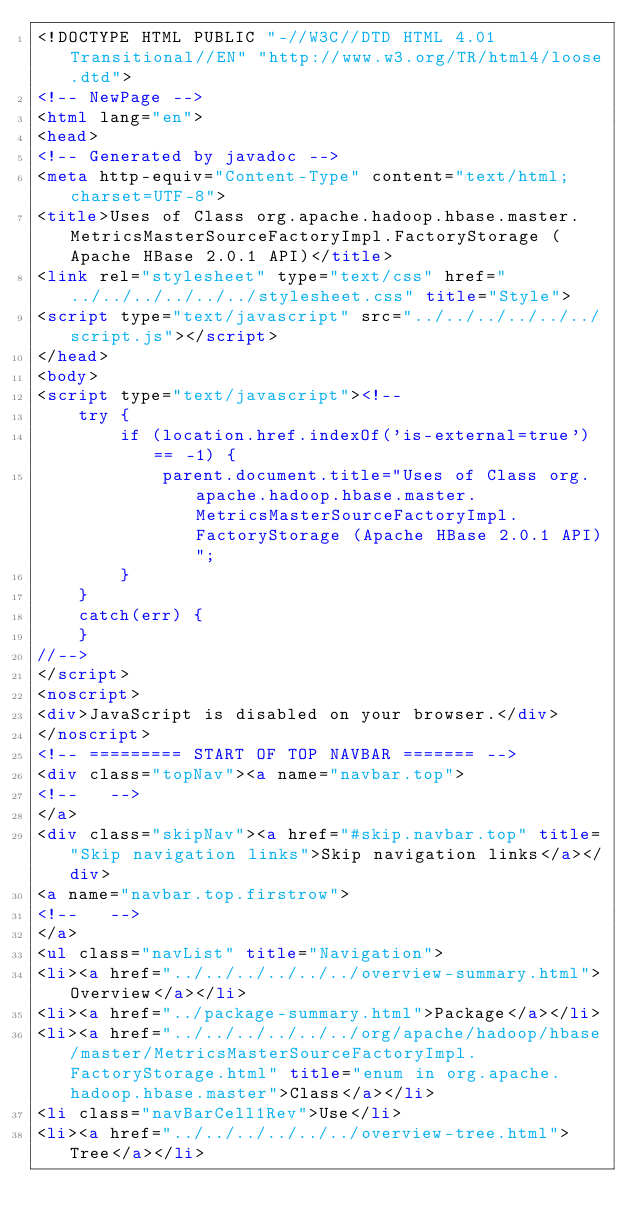Convert code to text. <code><loc_0><loc_0><loc_500><loc_500><_HTML_><!DOCTYPE HTML PUBLIC "-//W3C//DTD HTML 4.01 Transitional//EN" "http://www.w3.org/TR/html4/loose.dtd">
<!-- NewPage -->
<html lang="en">
<head>
<!-- Generated by javadoc -->
<meta http-equiv="Content-Type" content="text/html; charset=UTF-8">
<title>Uses of Class org.apache.hadoop.hbase.master.MetricsMasterSourceFactoryImpl.FactoryStorage (Apache HBase 2.0.1 API)</title>
<link rel="stylesheet" type="text/css" href="../../../../../../stylesheet.css" title="Style">
<script type="text/javascript" src="../../../../../../script.js"></script>
</head>
<body>
<script type="text/javascript"><!--
    try {
        if (location.href.indexOf('is-external=true') == -1) {
            parent.document.title="Uses of Class org.apache.hadoop.hbase.master.MetricsMasterSourceFactoryImpl.FactoryStorage (Apache HBase 2.0.1 API)";
        }
    }
    catch(err) {
    }
//-->
</script>
<noscript>
<div>JavaScript is disabled on your browser.</div>
</noscript>
<!-- ========= START OF TOP NAVBAR ======= -->
<div class="topNav"><a name="navbar.top">
<!--   -->
</a>
<div class="skipNav"><a href="#skip.navbar.top" title="Skip navigation links">Skip navigation links</a></div>
<a name="navbar.top.firstrow">
<!--   -->
</a>
<ul class="navList" title="Navigation">
<li><a href="../../../../../../overview-summary.html">Overview</a></li>
<li><a href="../package-summary.html">Package</a></li>
<li><a href="../../../../../../org/apache/hadoop/hbase/master/MetricsMasterSourceFactoryImpl.FactoryStorage.html" title="enum in org.apache.hadoop.hbase.master">Class</a></li>
<li class="navBarCell1Rev">Use</li>
<li><a href="../../../../../../overview-tree.html">Tree</a></li></code> 